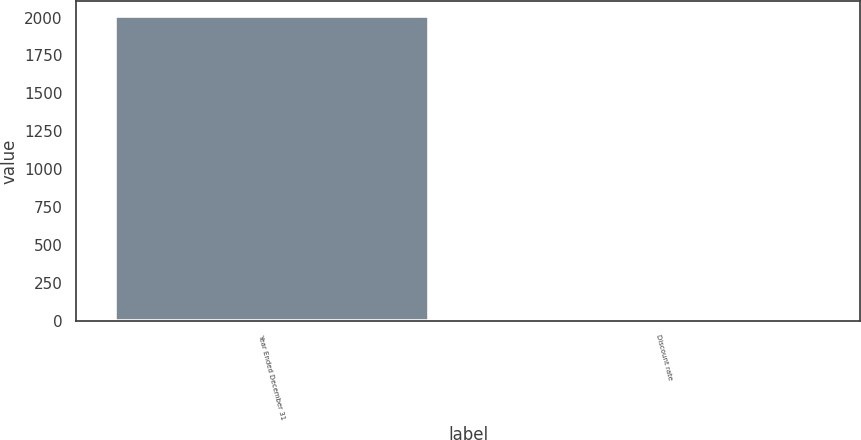Convert chart to OTSL. <chart><loc_0><loc_0><loc_500><loc_500><bar_chart><fcel>Year Ended December 31<fcel>Discount rate<nl><fcel>2007<fcel>5.7<nl></chart> 